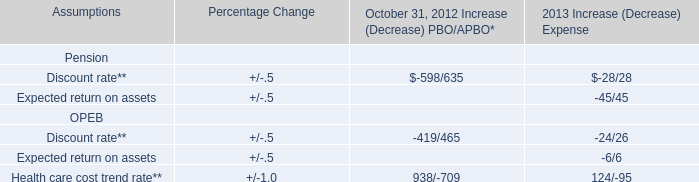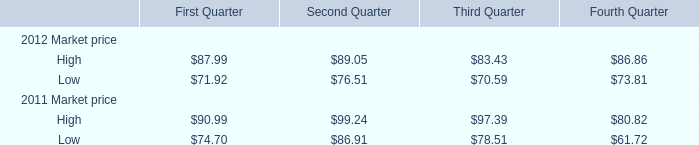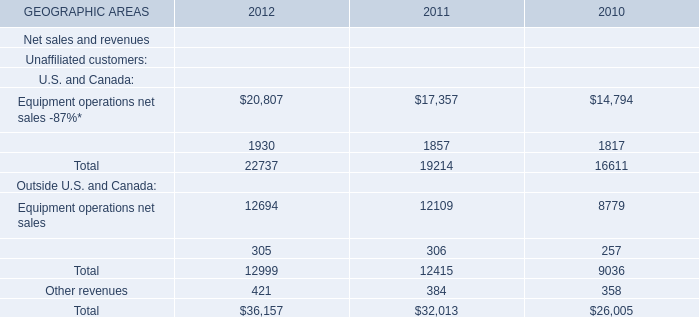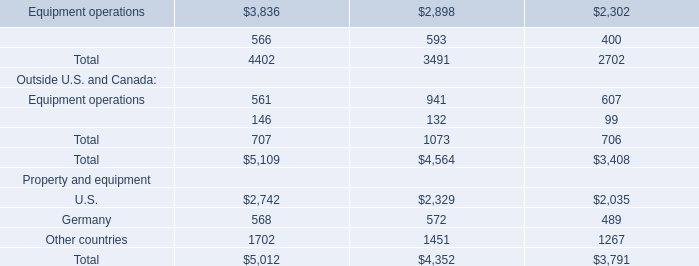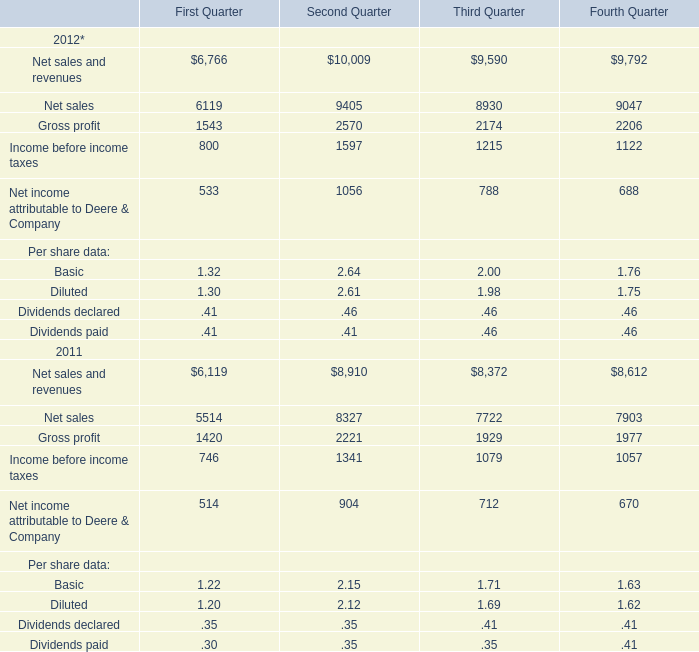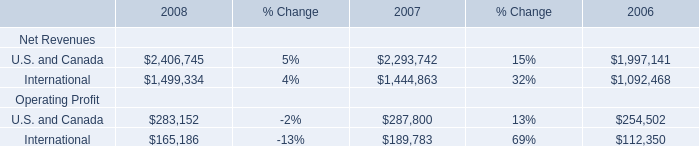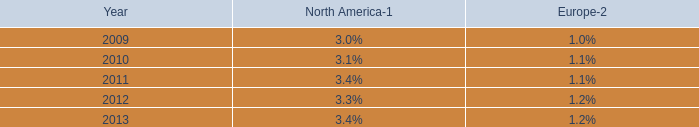by what percentage did the global cruise guests increase from 2011 to 2012 and from 2012 to 2013? 
Computations: ((21.3 - 20.9) / 20.9)
Answer: 0.01914. 